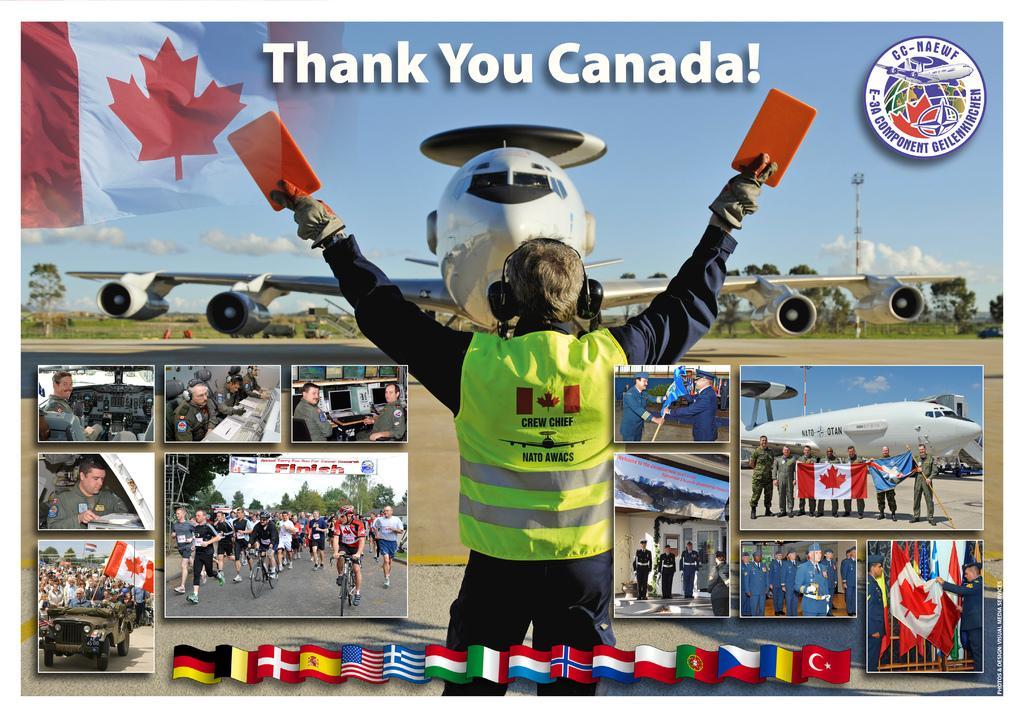How would you summarize this image in a sentence or two? This is an advertisement and here we can see logos, some text, an aeroplane and we can see trees and there is a person holding some objects and wearing gloves and safety jacket and there are some collage images of some people, bicycles, flags and some other objects. 